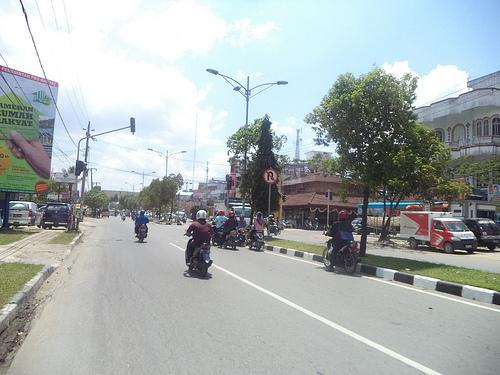Question: when was picture taken?
Choices:
A. Daytime.
B. Yesterday.
C. Today.
D. Noon.
Answer with the letter. Answer: A Question: what is white on the street?
Choices:
A. Car.
B. Motorcycle.
C. Line.
D. Bus.
Answer with the letter. Answer: C Question: why are bikers wearing helmets?
Choices:
A. It's the law.
B. Safety.
C. Decoration.
D. Protection.
Answer with the letter. Answer: D Question: what color is street?
Choices:
A. Black.
B. Grey.
C. White.
D. Brown.
Answer with the letter. Answer: B Question: where was picture taken?
Choices:
A. A bar.
B. A parade.
C. On the street.
D. The airport.
Answer with the letter. Answer: C 